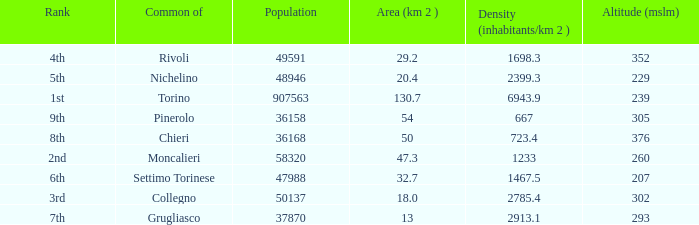What is the density of the common with an area of 20.4 km^2? 2399.3. 